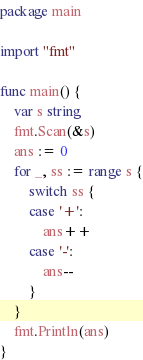Convert code to text. <code><loc_0><loc_0><loc_500><loc_500><_Go_>package main

import "fmt"

func main() {
	var s string
	fmt.Scan(&s)
	ans := 0
	for _, ss := range s {
		switch ss {
		case '+':
			ans++
		case '-':
			ans--
		}
	}
	fmt.Println(ans)
}
</code> 